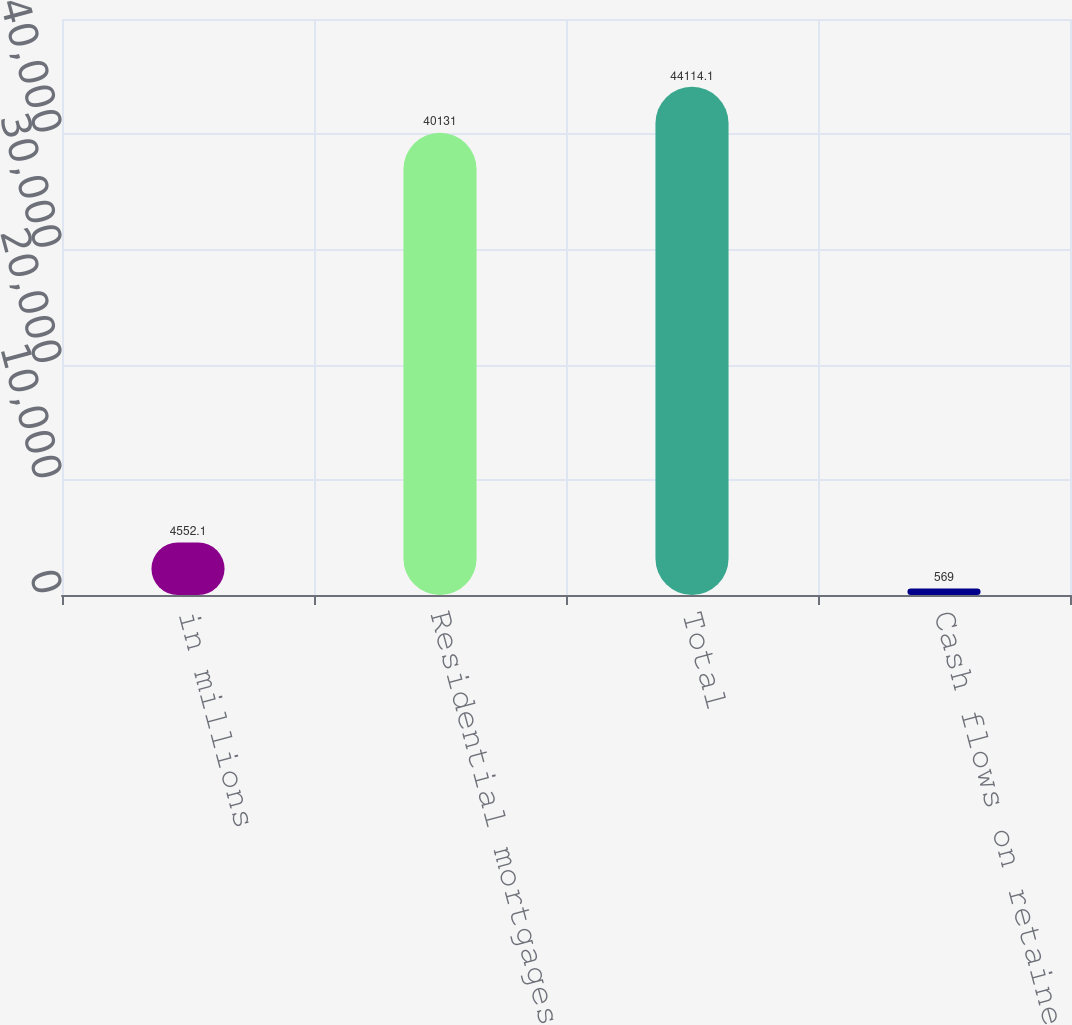Convert chart. <chart><loc_0><loc_0><loc_500><loc_500><bar_chart><fcel>in millions<fcel>Residential mortgages<fcel>Total<fcel>Cash flows on retained<nl><fcel>4552.1<fcel>40131<fcel>44114.1<fcel>569<nl></chart> 